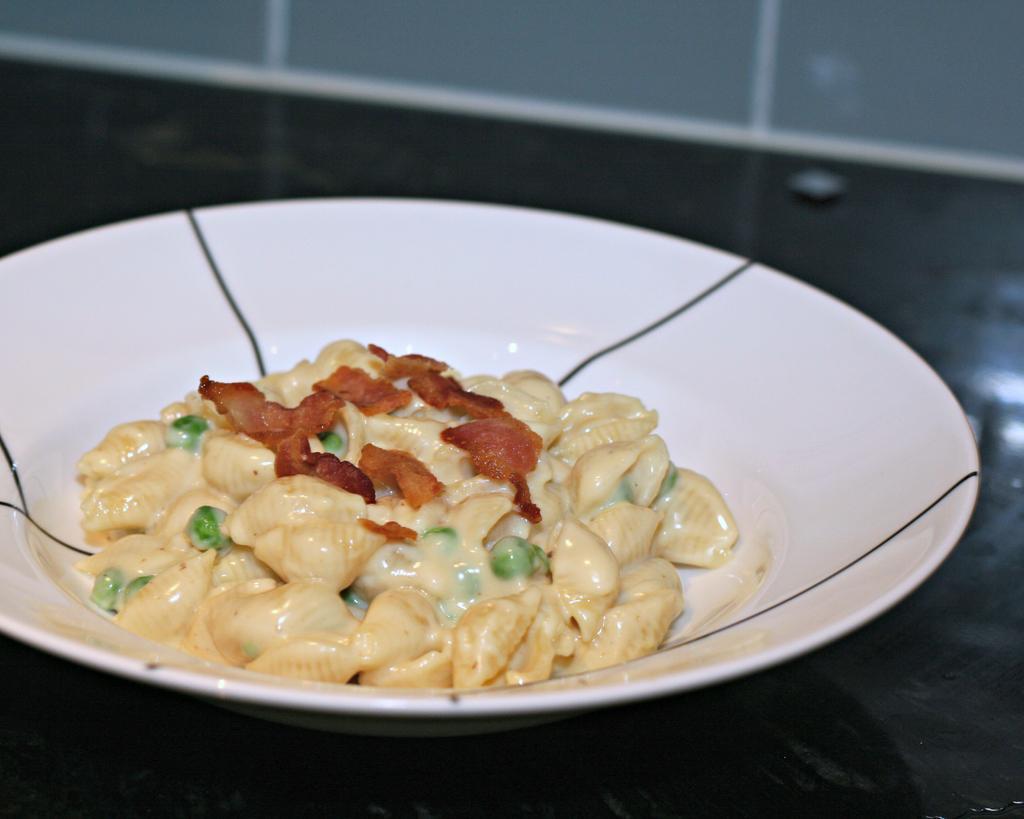In one or two sentences, can you explain what this image depicts? In this image we can see one white plate with food on the table and one object on the surface. 